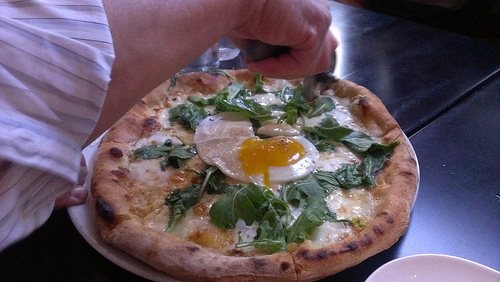Which side of the image is the cheese on? The cheese is on the right side of the image. 